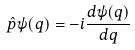<formula> <loc_0><loc_0><loc_500><loc_500>\hat { p } \psi ( q ) = - i \frac { d \psi ( q ) } { d q }</formula> 